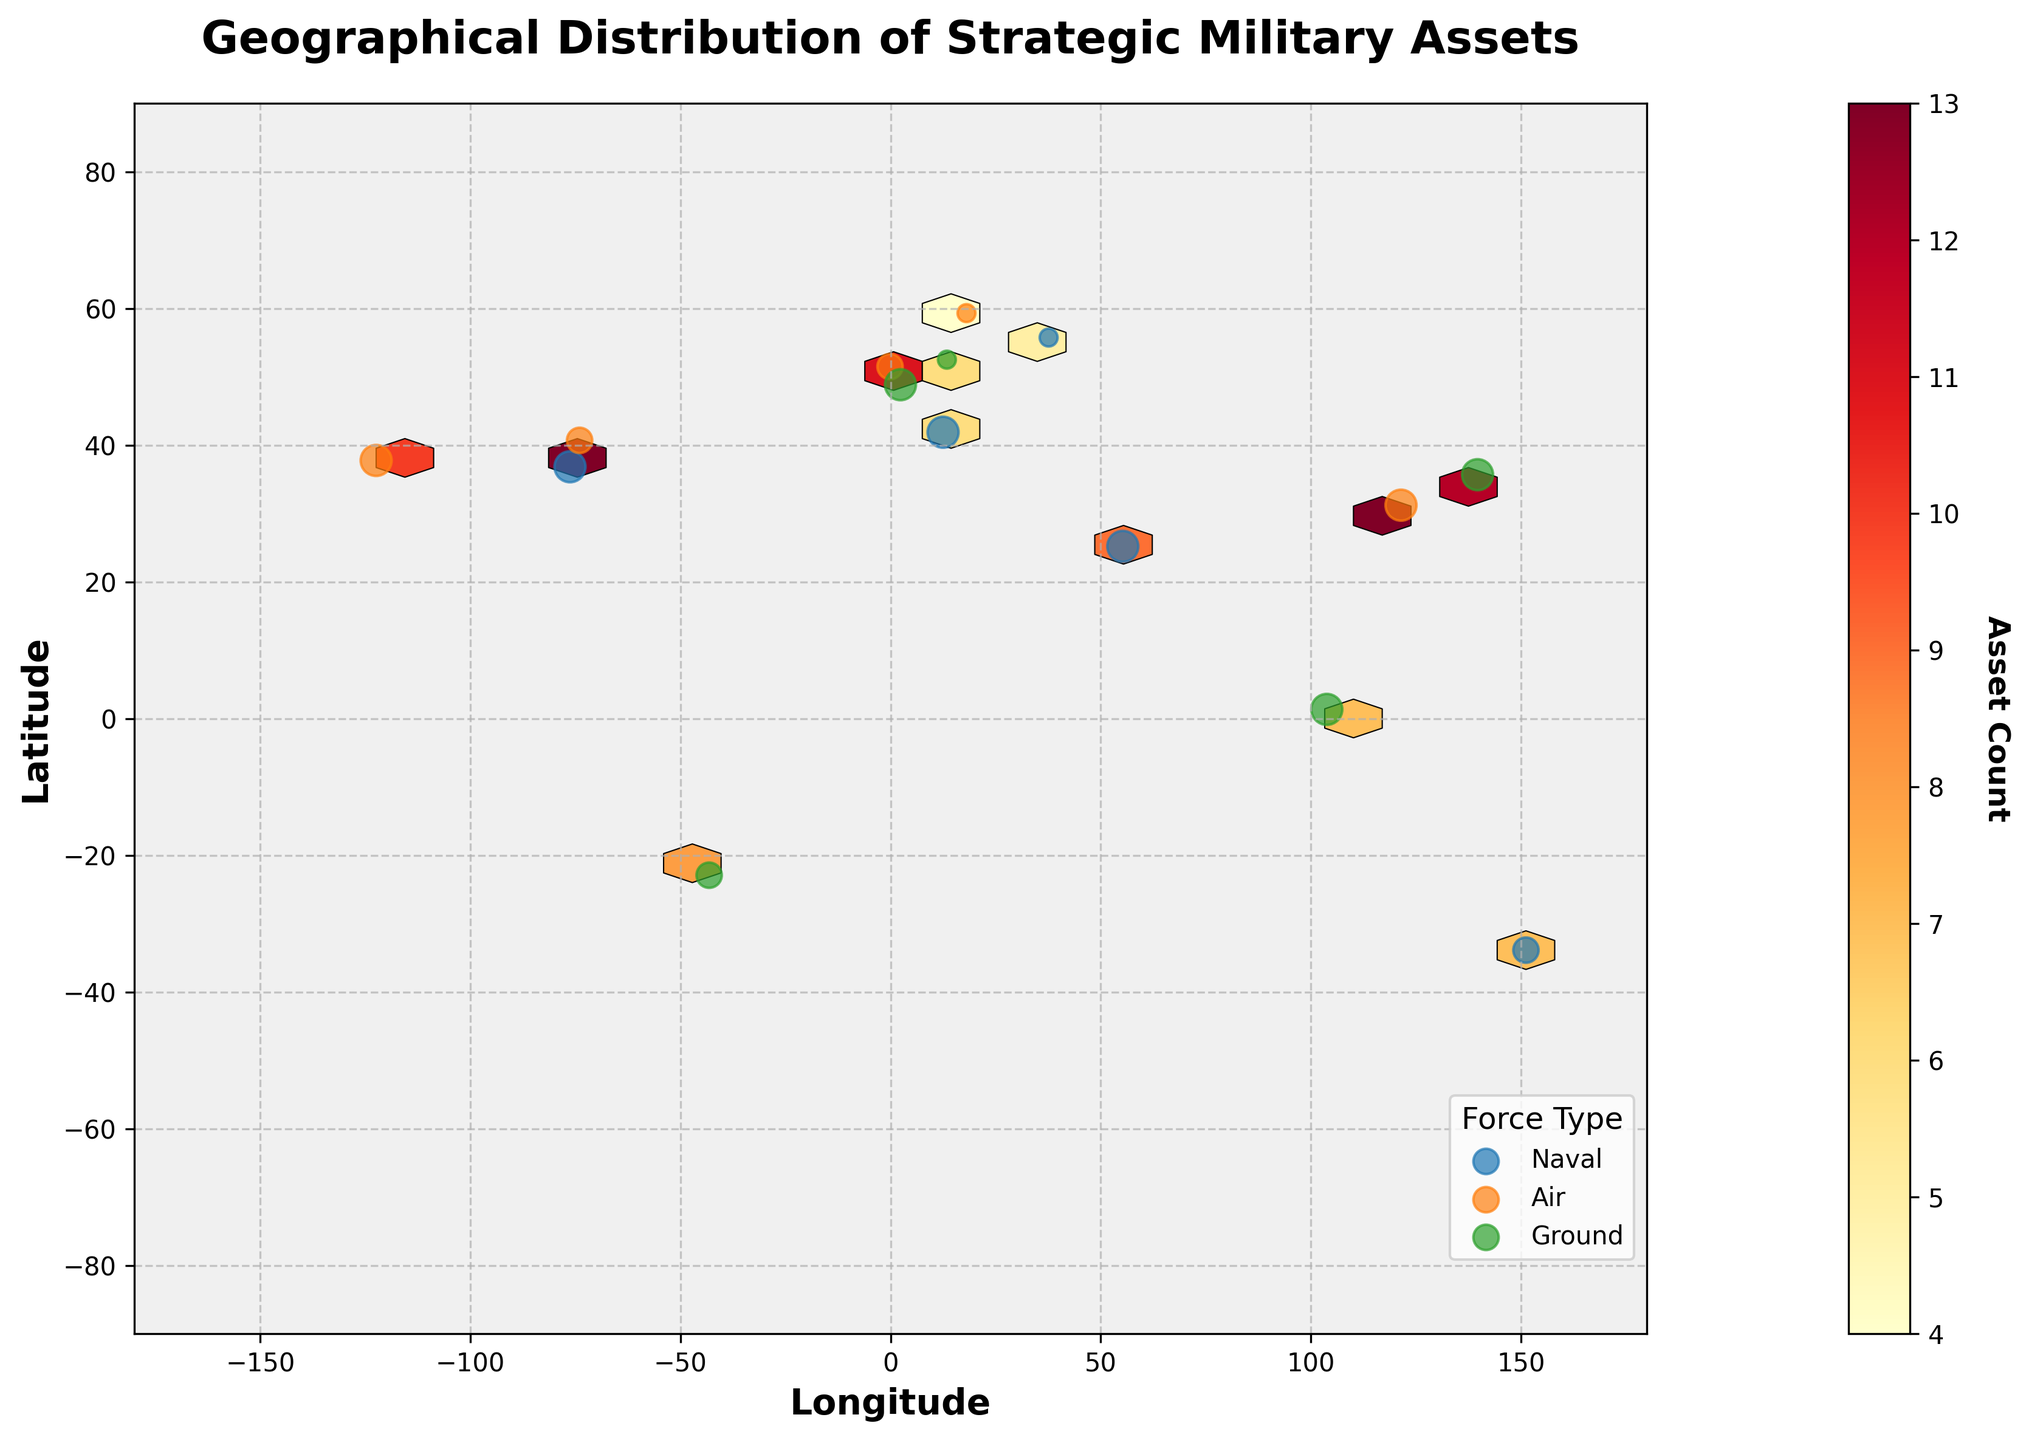What is the title of the figure? The title of the figure is located at the top of the plot and reads, "Geographical Distribution of Strategic Military Assets."
Answer: Geographical Distribution of Strategic Military Assets What does the color intensity on the hexbin plot represent? The color intensity on the hexbin plot is indicated by the color bar on the right side, which shows that it represents the 'Asset Count.'
Answer: Asset Count How is the readiness level visually represented in the figure? The readiness level is visually represented by the size of the scatter plot points, with larger sizes indicating higher readiness levels, as indicated in the legend.
Answer: By the size of the scatter points Which force type has the largest scatter point in Japan? The largest scatter point in Japan, located around the coordinates (35.6895, 139.6917), belongs to the 'Ground' forces with a high readiness level.
Answer: Ground Compare the number of 'High' readiness naval assets between Sydney and New York. Which city has more? Sydney is represented at coordinates (-33.8688, 151.2093) and has Navy assets with 'Medium' readiness. New York, represented at coordinates (40.7128, -74.0060), has Air assets with 'Medium' readiness, not Naval assets. Thus, Sydney has more 'High' readiness naval assets.
Answer: Sydney Which region appears to have the highest concentration of military assets? The highest concentration of military assets can be inferred from the density of the hexbin cells and is primarily seen around the coordinates representing Europe and East Asia, particularly around Berlin and Tokyo.
Answer: Europe and East Asia What is the asset count in Paris, and what is the readiness level? In Paris, located around coordinates (48.8566, 2.3522), the asset count is 14, and the readiness level is 'High.'
Answer: 14 and High How are the naval assets distributed across the world? The naval assets are scattered in various global locations including the USA (Norfolk), Australia (Sydney), Dubai, Russia, and Italy, represented by different readiness levels indicated by the scatter plot sizes.
Answer: Scattered globally in various regions Based on the color intensity, which tactical genre has the least number of assets in low readiness? The legend combined with color intensity and scatter sizes shows that 'Ground' forces (Berlin) and 'Air' forces (Stockholm) have a low readiness level, with 'Air' forces in Stockholm having the least intense color, indicating the least number of assets.
Answer: Air Forces 